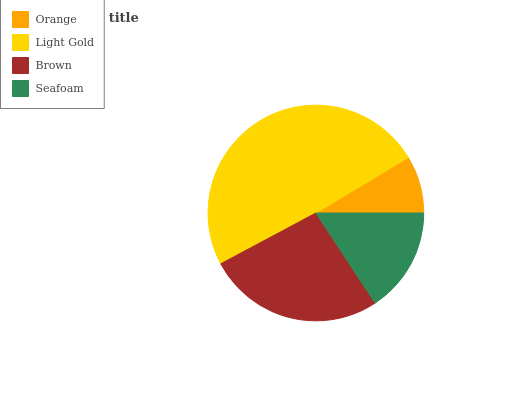Is Orange the minimum?
Answer yes or no. Yes. Is Light Gold the maximum?
Answer yes or no. Yes. Is Brown the minimum?
Answer yes or no. No. Is Brown the maximum?
Answer yes or no. No. Is Light Gold greater than Brown?
Answer yes or no. Yes. Is Brown less than Light Gold?
Answer yes or no. Yes. Is Brown greater than Light Gold?
Answer yes or no. No. Is Light Gold less than Brown?
Answer yes or no. No. Is Brown the high median?
Answer yes or no. Yes. Is Seafoam the low median?
Answer yes or no. Yes. Is Orange the high median?
Answer yes or no. No. Is Brown the low median?
Answer yes or no. No. 